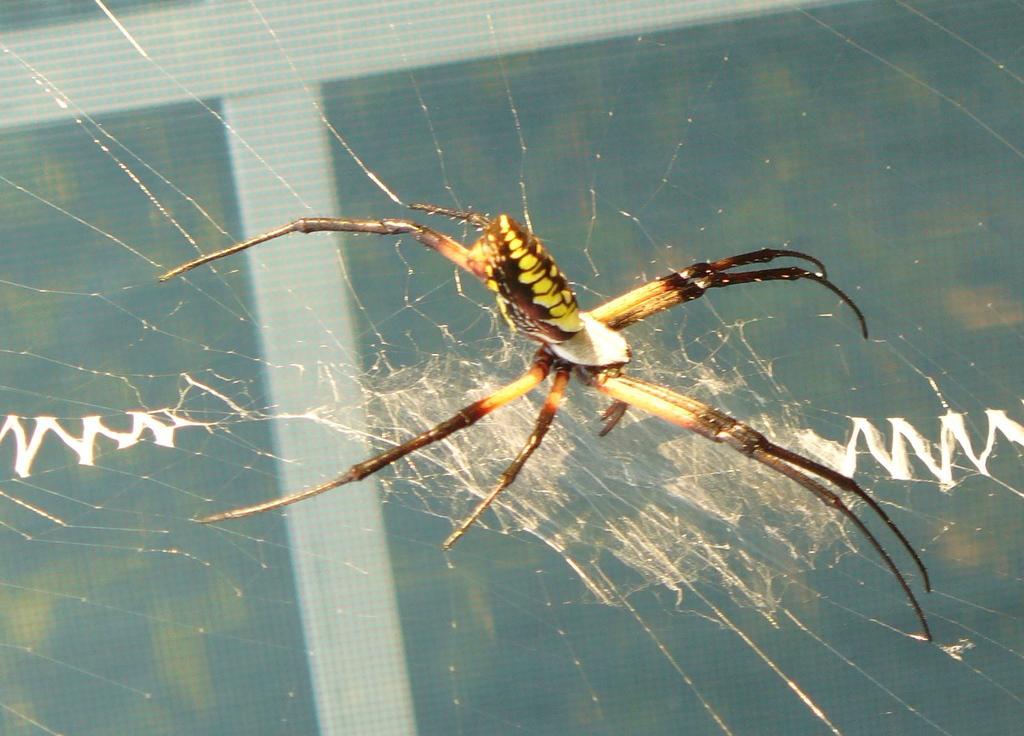Can you describe this image briefly? It is a spider in the web. 